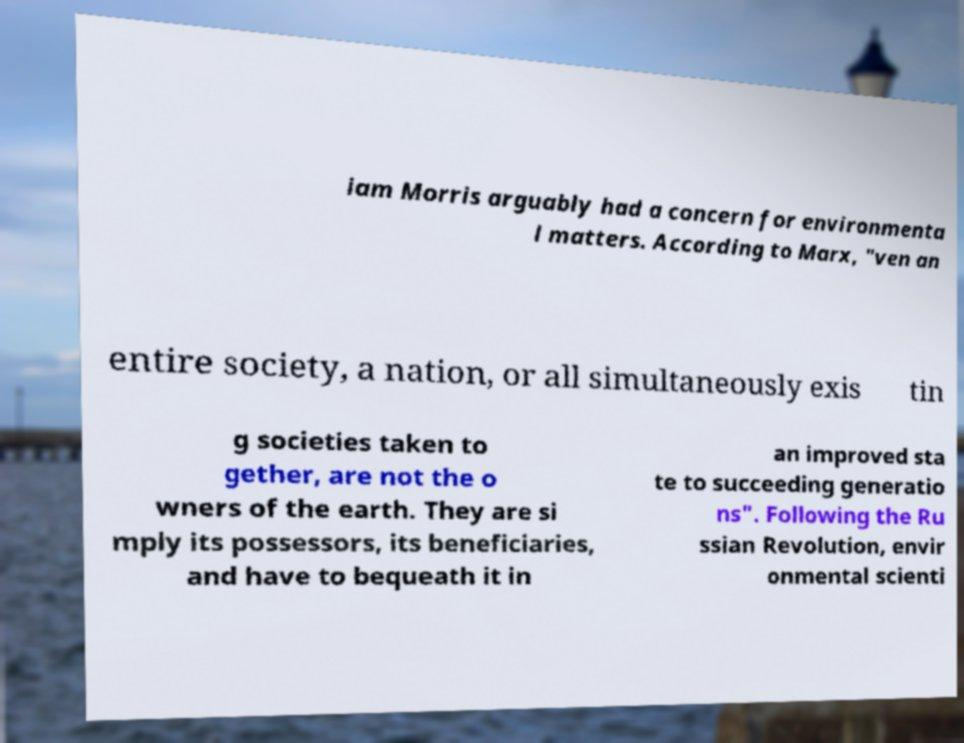What messages or text are displayed in this image? I need them in a readable, typed format. iam Morris arguably had a concern for environmenta l matters. According to Marx, "ven an entire society, a nation, or all simultaneously exis tin g societies taken to gether, are not the o wners of the earth. They are si mply its possessors, its beneficiaries, and have to bequeath it in an improved sta te to succeeding generatio ns". Following the Ru ssian Revolution, envir onmental scienti 